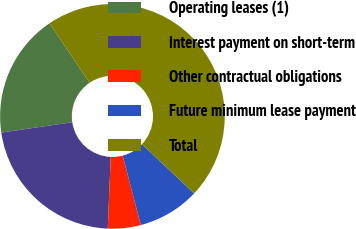Convert chart to OTSL. <chart><loc_0><loc_0><loc_500><loc_500><pie_chart><fcel>Operating leases (1)<fcel>Interest payment on short-term<fcel>Other contractual obligations<fcel>Future minimum lease payment<fcel>Total<nl><fcel>17.85%<fcel>22.03%<fcel>4.73%<fcel>8.9%<fcel>46.49%<nl></chart> 